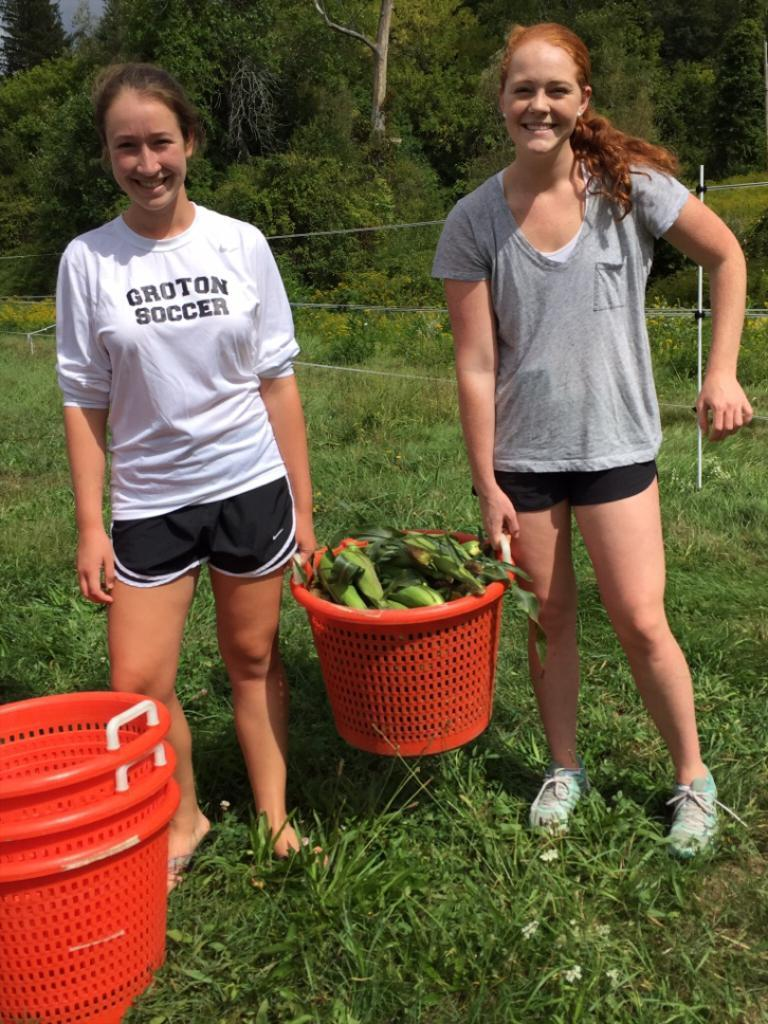<image>
Create a compact narrative representing the image presented. One of the girls have GRUTON SOCCER  printed on the shirt they are wearing. 